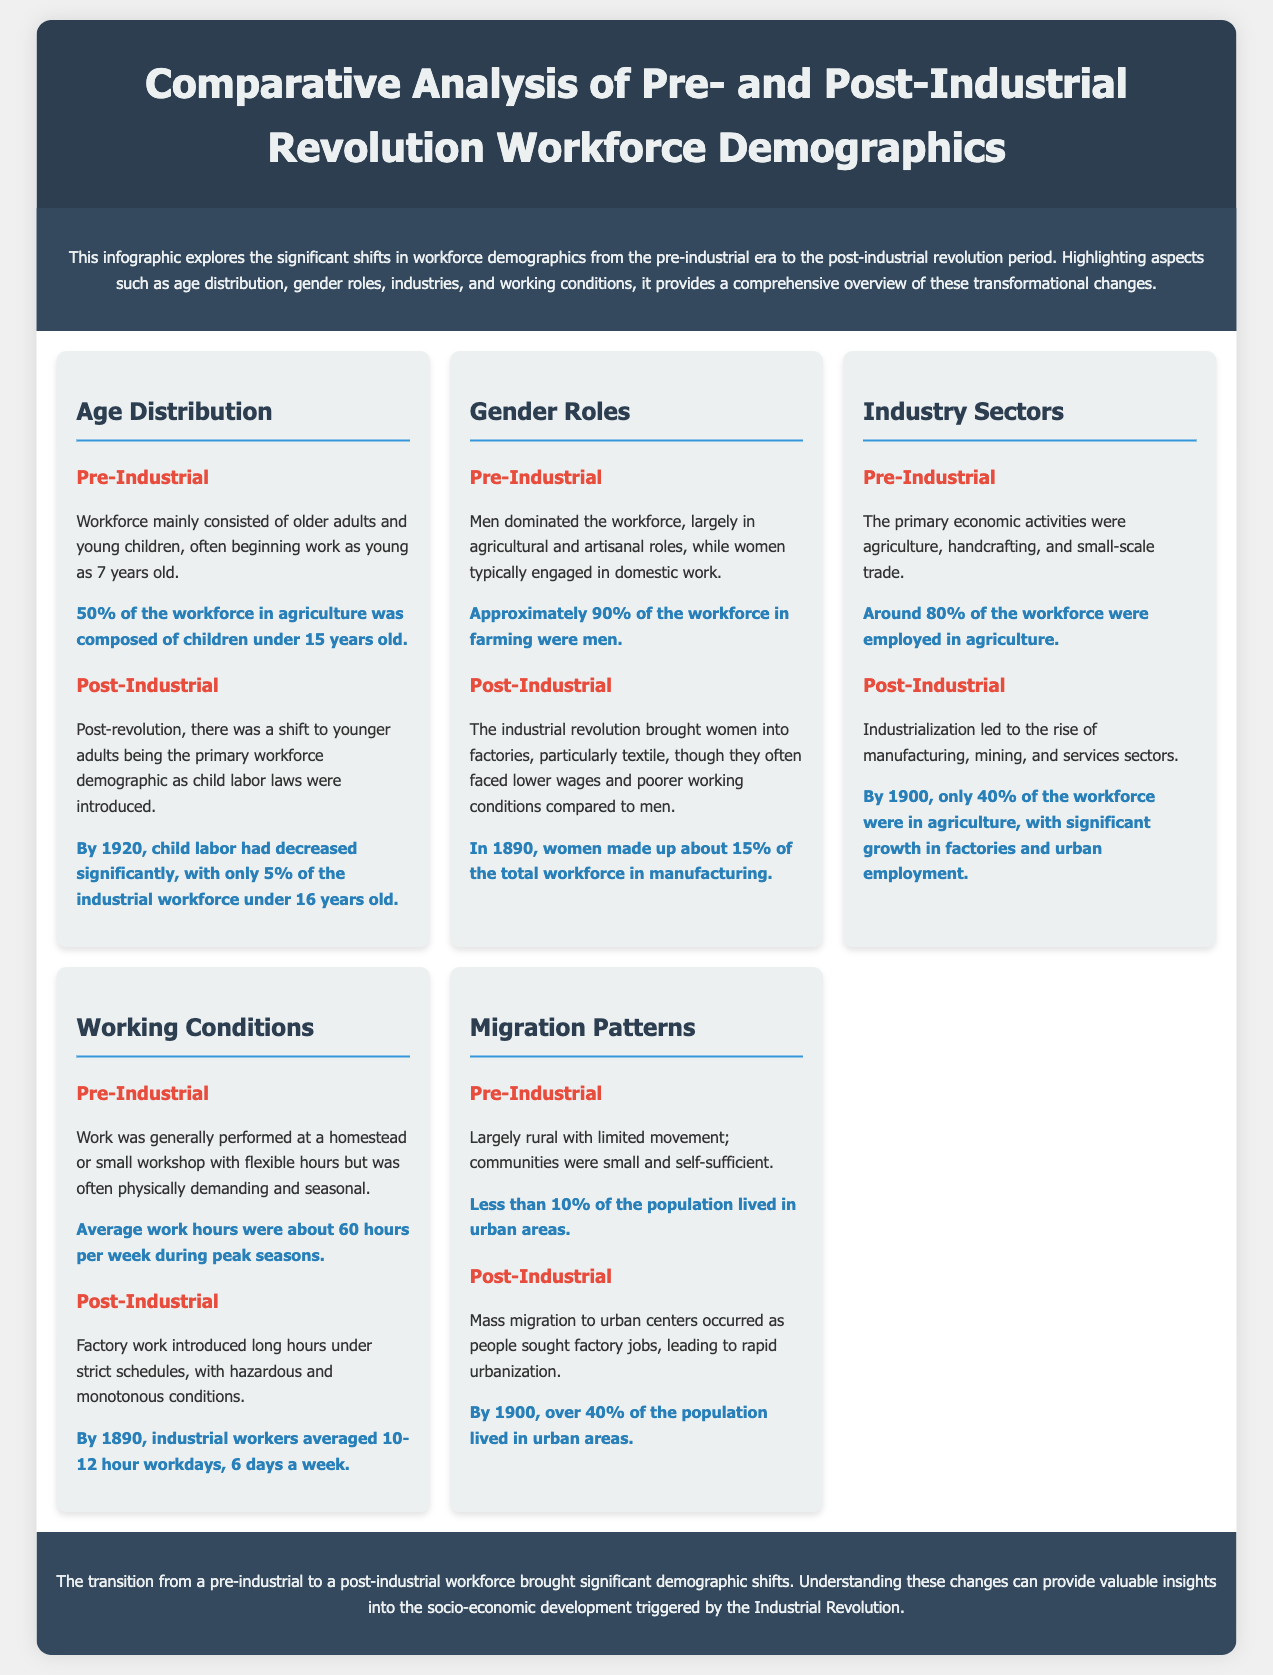What percentage of the pre-industrial workforce was made up of children under 15 years old? The document states that 50% of the workforce in agriculture was composed of children under 15 years old.
Answer: 50% By what year had child labor decreased to only 5% of the industrial workforce under 16 years old? It mentions that by 1920, child labor had decreased significantly.
Answer: 1920 What percentage of the workforce in farming were men during the pre-industrial era? The document notes that approximately 90% of the workforce in farming were men.
Answer: 90% What percentage of the workforce was employed in agriculture post-industrial revolution by 1900? It states that by 1900, only 40% of the workforce were in agriculture.
Answer: 40% What were the average work hours during peak seasons in the pre-industrial era? The average work hours were about 60 hours per week during peak seasons.
Answer: 60 hours How much did women's representation in the manufacturing workforce grow to by 1890? The infographic indicates that women made up about 15% of the total workforce in manufacturing.
Answer: 15% What was the living condition for less than 10% of the population before the industrial revolution? It mentions that less than 10% of the population lived in urban areas, indicating a largely rural existence.
Answer: rural What significant change in population distribution occurred by 1900? It highlights that over 40% of the population lived in urban areas by 1900, indicating mass migration.
Answer: urban What type of document is this aimed at illustrating major demographic shifts? The document presents a comparative analysis focusing on workforce demographics before and after the industrial revolution.
Answer: infographic 